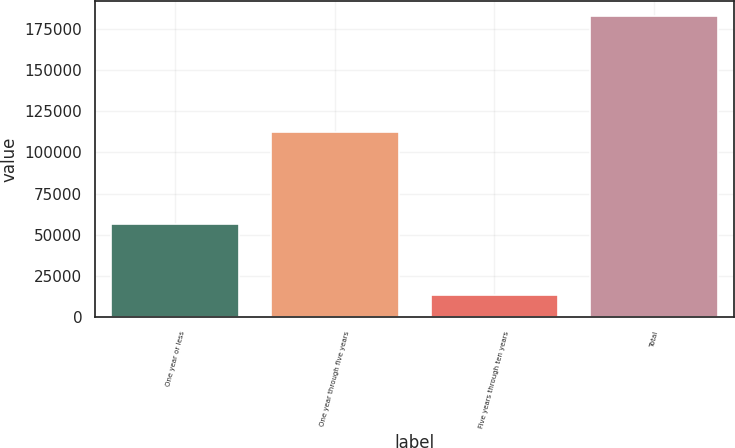Convert chart. <chart><loc_0><loc_0><loc_500><loc_500><bar_chart><fcel>One year or less<fcel>One year through five years<fcel>Five years through ten years<fcel>Total<nl><fcel>56863<fcel>112623<fcel>13416<fcel>182902<nl></chart> 